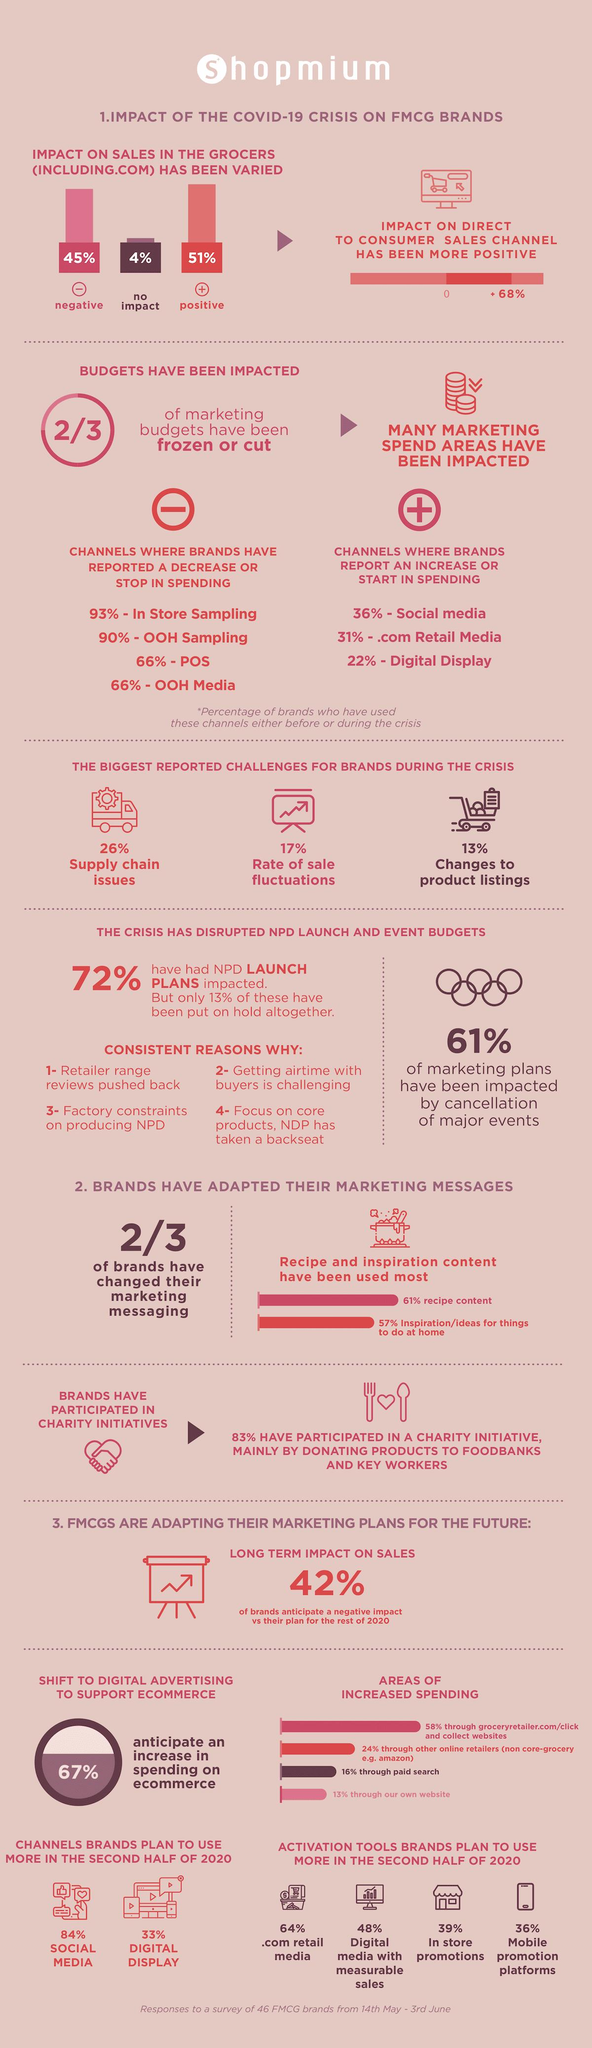List a handful of essential elements in this visual. According to a recent study, COVID-19 has had a negative impact of 45% on the sales of FMCG product brands in grocery stores. According to the impact of COVID-19 on the sales of FMCG product brands in grocery stores, 51% of the positive impact can be attributed to this pandemic. 